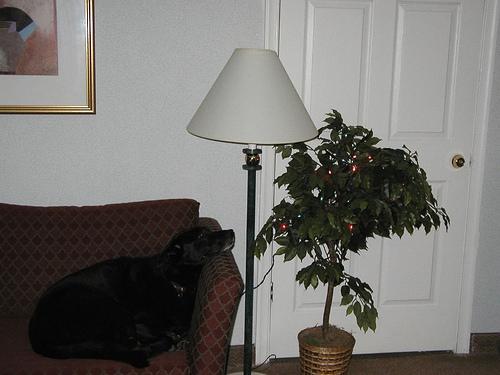What color is the lampshade?
Write a very short answer. White. Is the dog resting?
Concise answer only. Yes. What color is the frame around the picture?
Keep it brief. Gold. What kind of plant is in the pot?
Answer briefly. Tree. 